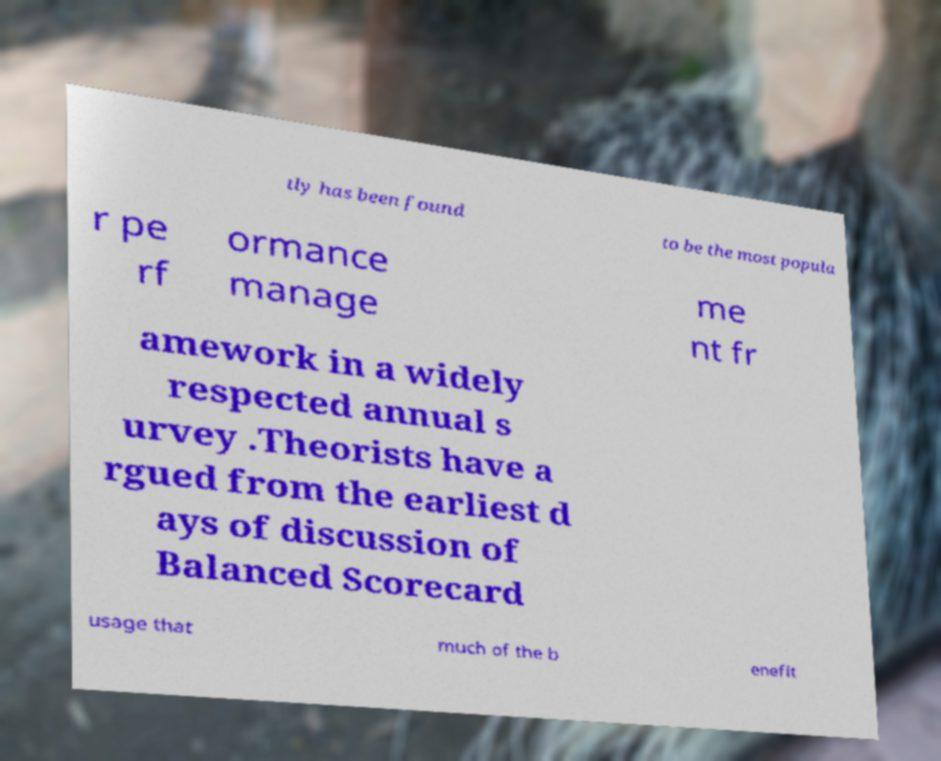For documentation purposes, I need the text within this image transcribed. Could you provide that? tly has been found to be the most popula r pe rf ormance manage me nt fr amework in a widely respected annual s urvey .Theorists have a rgued from the earliest d ays of discussion of Balanced Scorecard usage that much of the b enefit 